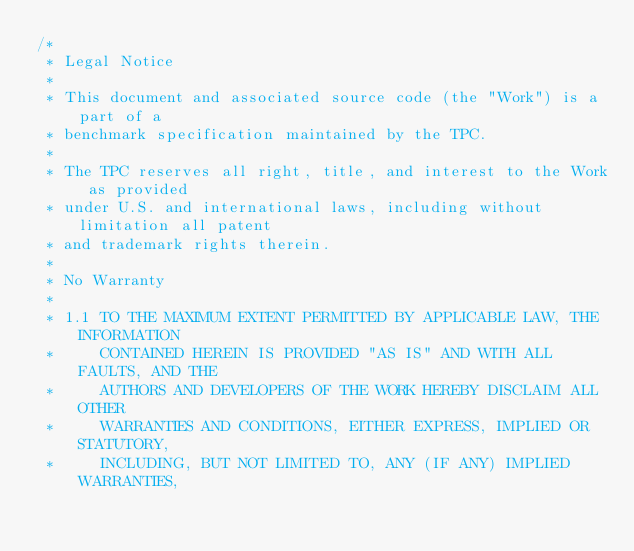Convert code to text. <code><loc_0><loc_0><loc_500><loc_500><_C_>/*
 * Legal Notice
 *
 * This document and associated source code (the "Work") is a part of a
 * benchmark specification maintained by the TPC.
 *
 * The TPC reserves all right, title, and interest to the Work as provided
 * under U.S. and international laws, including without limitation all patent
 * and trademark rights therein.
 *
 * No Warranty
 *
 * 1.1 TO THE MAXIMUM EXTENT PERMITTED BY APPLICABLE LAW, THE INFORMATION
 *     CONTAINED HEREIN IS PROVIDED "AS IS" AND WITH ALL FAULTS, AND THE
 *     AUTHORS AND DEVELOPERS OF THE WORK HEREBY DISCLAIM ALL OTHER
 *     WARRANTIES AND CONDITIONS, EITHER EXPRESS, IMPLIED OR STATUTORY,
 *     INCLUDING, BUT NOT LIMITED TO, ANY (IF ANY) IMPLIED WARRANTIES,</code> 